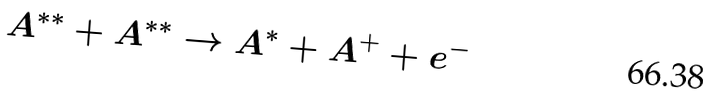<formula> <loc_0><loc_0><loc_500><loc_500>A ^ { * * } + A ^ { * * } \rightarrow A ^ { * } + A ^ { + } + e ^ { - }</formula> 